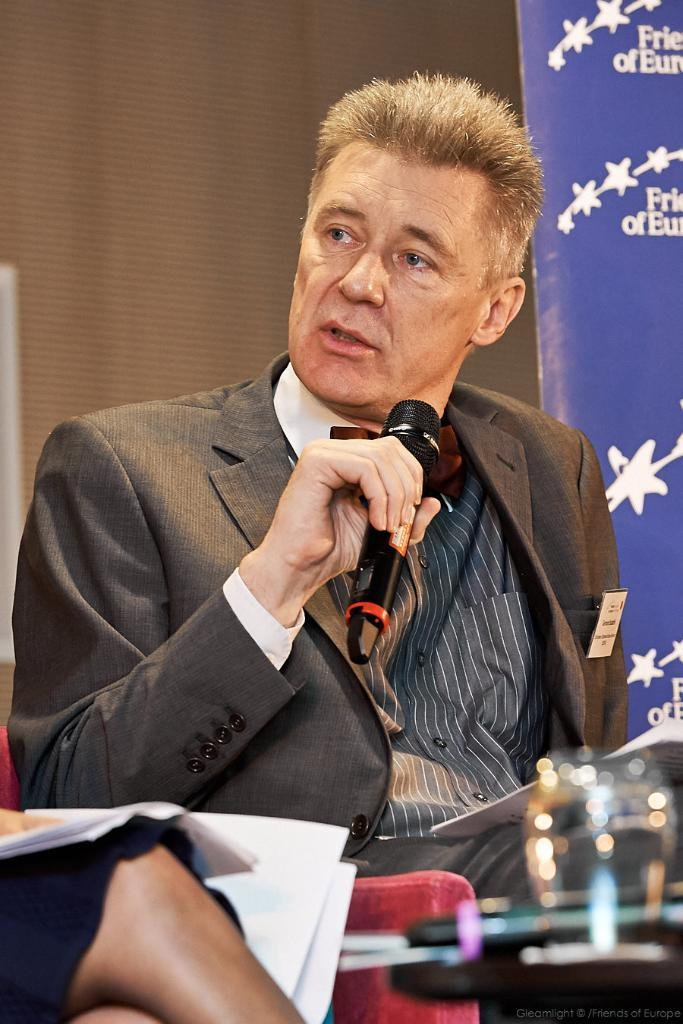What is the man in the image holding? The man is holding a mic in the image. What might the man be doing with the mic? The man might be using the mic for speaking or singing. Can you describe the background of the image? There is a banner behind the man in the image. Is the man wearing a mask in the image? There is no mention of a mask in the image, so we cannot determine if the man is wearing one. 